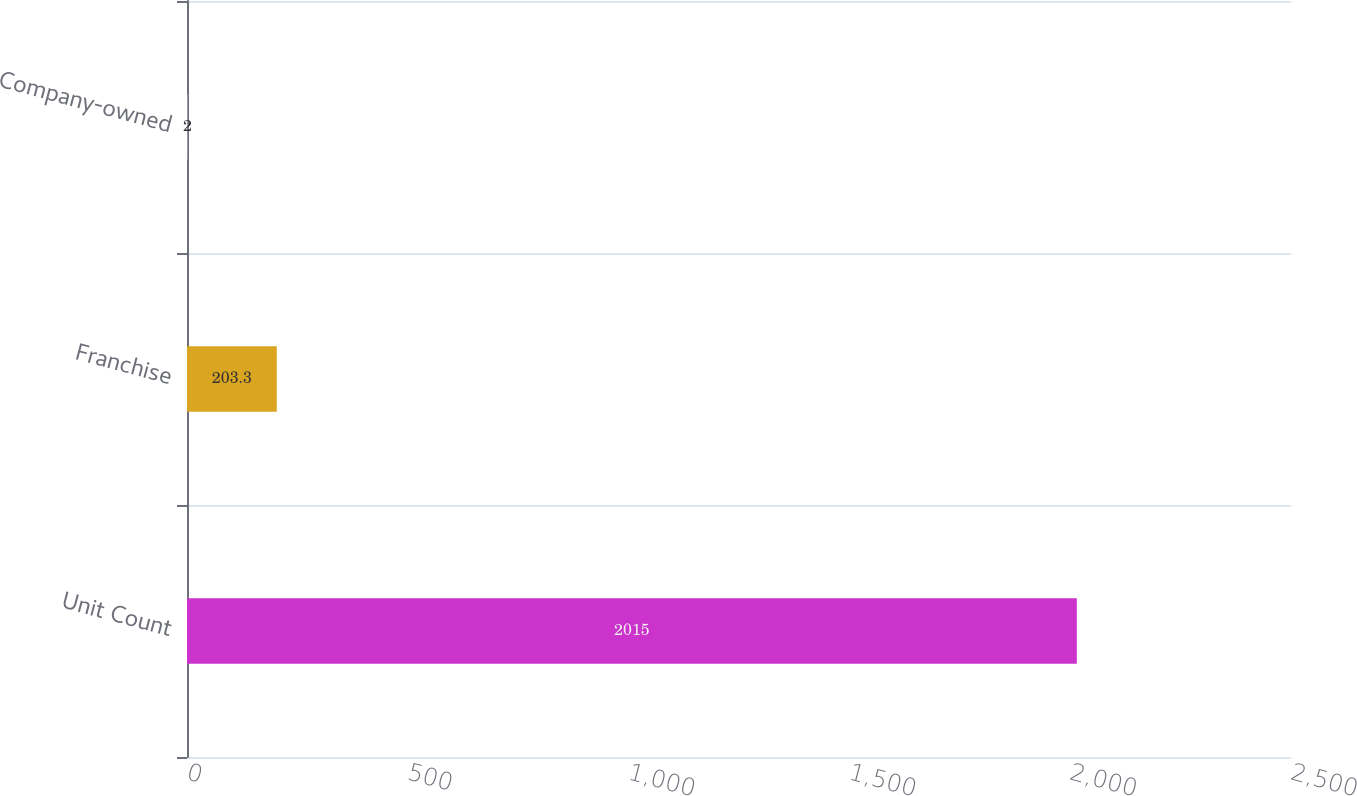Convert chart to OTSL. <chart><loc_0><loc_0><loc_500><loc_500><bar_chart><fcel>Unit Count<fcel>Franchise<fcel>Company-owned<nl><fcel>2015<fcel>203.3<fcel>2<nl></chart> 